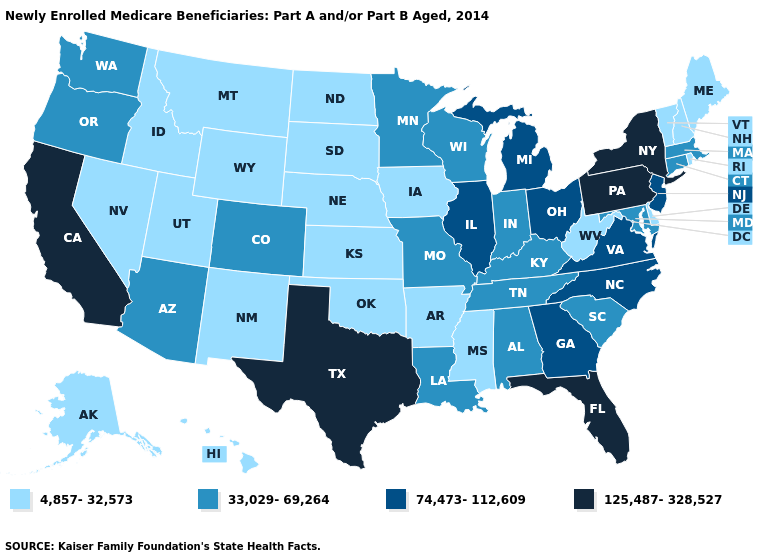Which states have the lowest value in the USA?
Concise answer only. Alaska, Arkansas, Delaware, Hawaii, Idaho, Iowa, Kansas, Maine, Mississippi, Montana, Nebraska, Nevada, New Hampshire, New Mexico, North Dakota, Oklahoma, Rhode Island, South Dakota, Utah, Vermont, West Virginia, Wyoming. Name the states that have a value in the range 125,487-328,527?
Keep it brief. California, Florida, New York, Pennsylvania, Texas. What is the highest value in states that border Pennsylvania?
Answer briefly. 125,487-328,527. What is the highest value in the USA?
Quick response, please. 125,487-328,527. What is the value of Washington?
Short answer required. 33,029-69,264. Among the states that border Mississippi , does Arkansas have the highest value?
Quick response, please. No. What is the value of Alabama?
Quick response, please. 33,029-69,264. Which states have the highest value in the USA?
Write a very short answer. California, Florida, New York, Pennsylvania, Texas. Does New York have the highest value in the Northeast?
Concise answer only. Yes. What is the value of Georgia?
Keep it brief. 74,473-112,609. Which states have the lowest value in the USA?
Be succinct. Alaska, Arkansas, Delaware, Hawaii, Idaho, Iowa, Kansas, Maine, Mississippi, Montana, Nebraska, Nevada, New Hampshire, New Mexico, North Dakota, Oklahoma, Rhode Island, South Dakota, Utah, Vermont, West Virginia, Wyoming. What is the value of Kentucky?
Concise answer only. 33,029-69,264. Does Idaho have a higher value than Massachusetts?
Concise answer only. No. What is the value of North Dakota?
Write a very short answer. 4,857-32,573. What is the lowest value in states that border Indiana?
Be succinct. 33,029-69,264. 